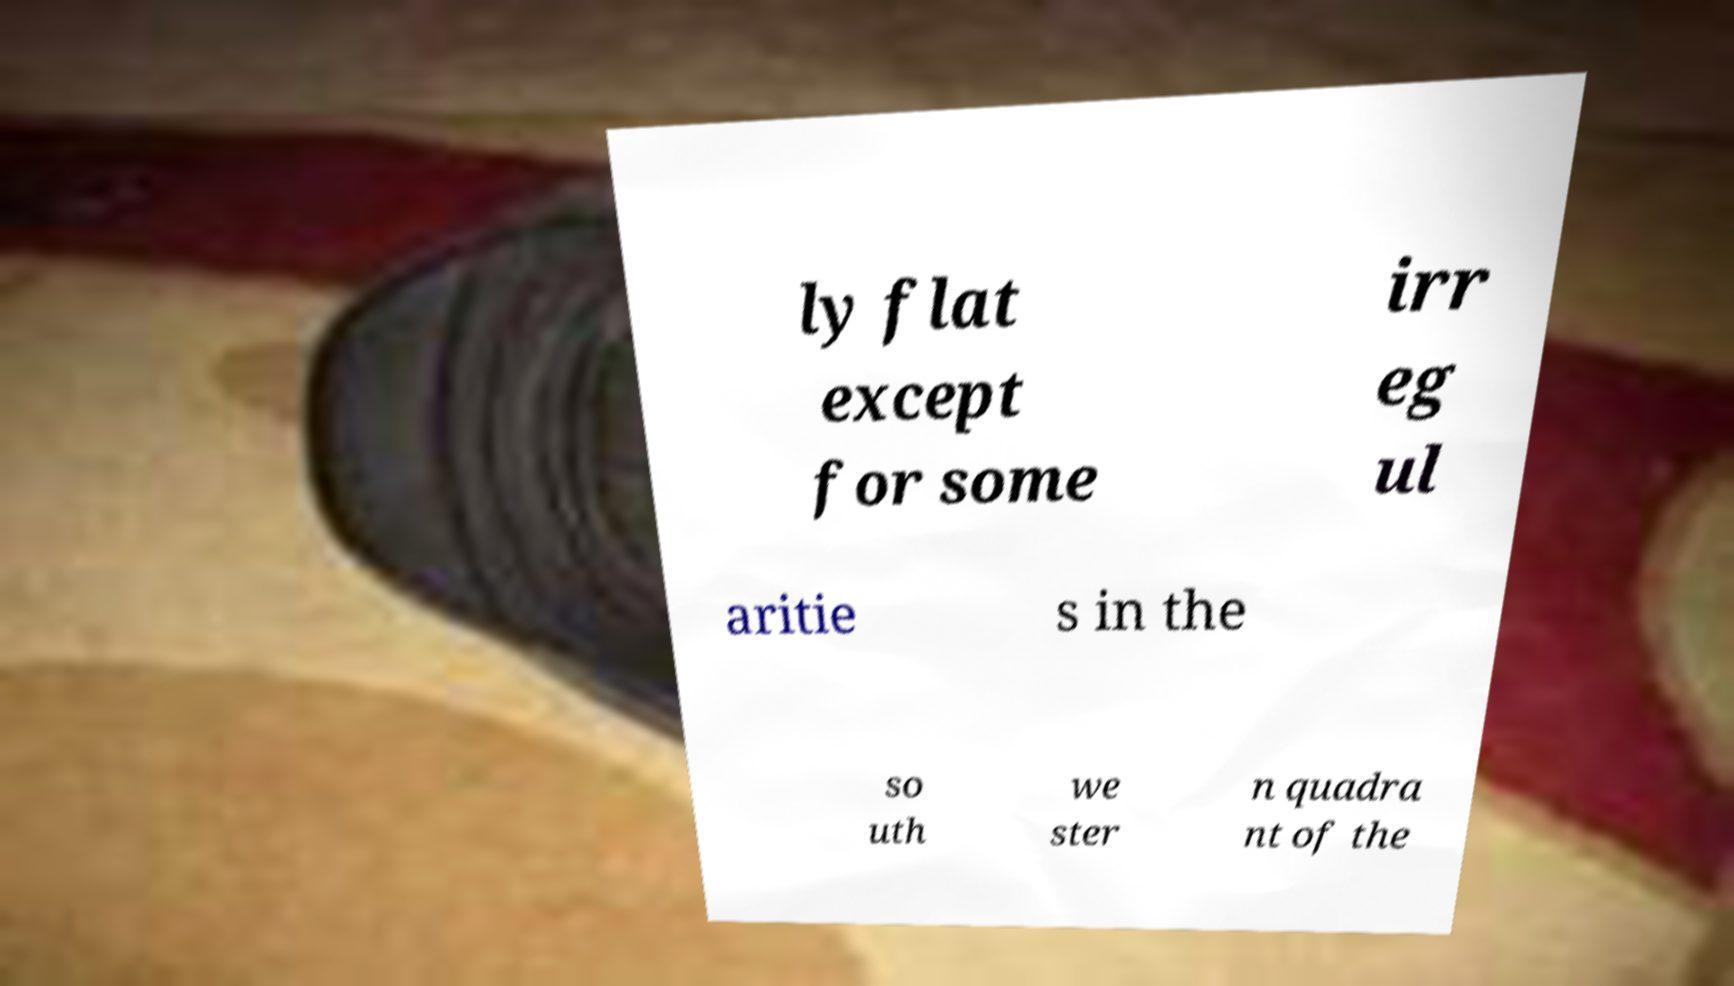There's text embedded in this image that I need extracted. Can you transcribe it verbatim? ly flat except for some irr eg ul aritie s in the so uth we ster n quadra nt of the 